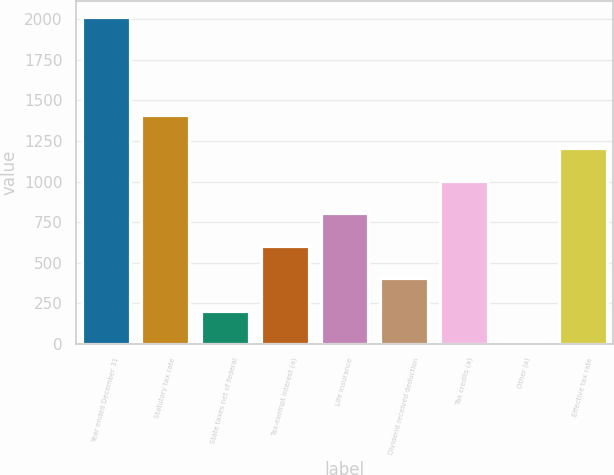Convert chart to OTSL. <chart><loc_0><loc_0><loc_500><loc_500><bar_chart><fcel>Year ended December 31<fcel>Statutory tax rate<fcel>State taxes net of federal<fcel>Tax-exempt interest (a)<fcel>Life insurance<fcel>Dividend received deduction<fcel>Tax credits (a)<fcel>Other (a)<fcel>Effective tax rate<nl><fcel>2012<fcel>1408.52<fcel>201.56<fcel>603.88<fcel>805.04<fcel>402.72<fcel>1006.2<fcel>0.4<fcel>1207.36<nl></chart> 